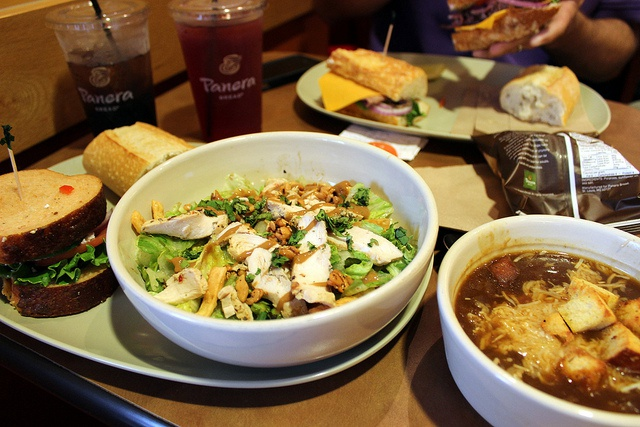Describe the objects in this image and their specific colors. I can see dining table in brown, black, olive, maroon, and khaki tones, bowl in brown, khaki, beige, and tan tones, bowl in brown, maroon, lightgray, and gray tones, people in brown, black, and maroon tones, and sandwich in brown, black, orange, and maroon tones in this image. 